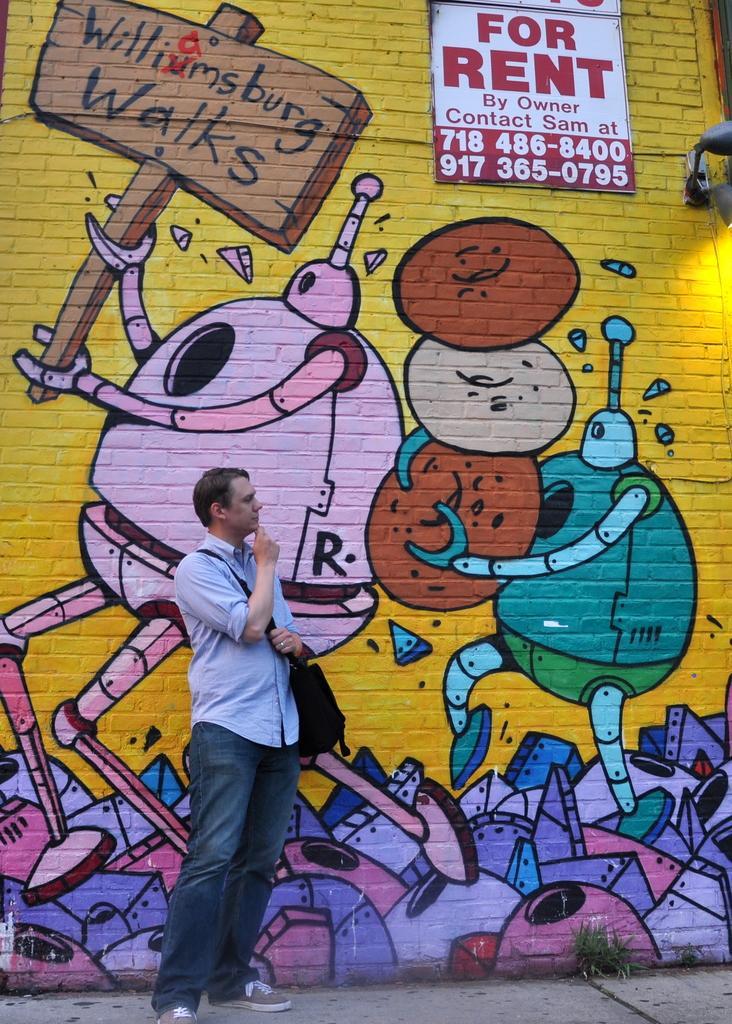Describe this image in one or two sentences. In this image we can see a man holding a bag and standing on the path and behind the man we can see a graffiti on the brick wall. We can also see the text board and also numbers. Grass is also visible in this image. 